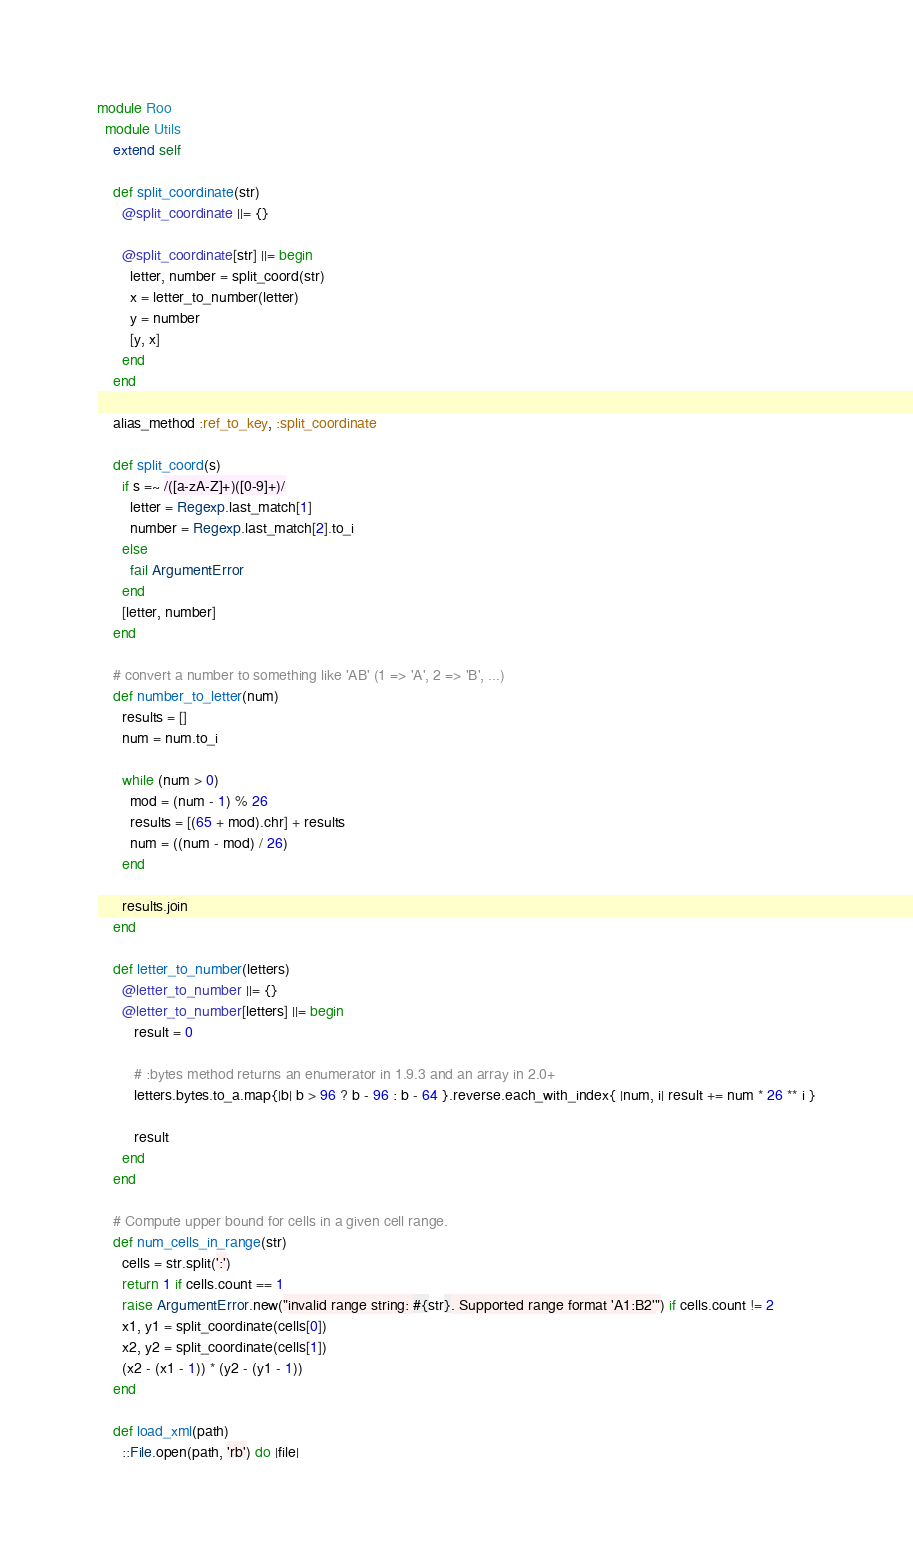Convert code to text. <code><loc_0><loc_0><loc_500><loc_500><_Ruby_>module Roo
  module Utils
    extend self

    def split_coordinate(str)
      @split_coordinate ||= {}

      @split_coordinate[str] ||= begin
        letter, number = split_coord(str)
        x = letter_to_number(letter)
        y = number
        [y, x]
      end
    end

    alias_method :ref_to_key, :split_coordinate

    def split_coord(s)
      if s =~ /([a-zA-Z]+)([0-9]+)/
        letter = Regexp.last_match[1]
        number = Regexp.last_match[2].to_i
      else
        fail ArgumentError
      end
      [letter, number]
    end

    # convert a number to something like 'AB' (1 => 'A', 2 => 'B', ...)
    def number_to_letter(num)
      results = []
      num = num.to_i

      while (num > 0)
        mod = (num - 1) % 26
        results = [(65 + mod).chr] + results
        num = ((num - mod) / 26)
      end

      results.join
    end

    def letter_to_number(letters)
      @letter_to_number ||= {}
      @letter_to_number[letters] ||= begin
         result = 0

         # :bytes method returns an enumerator in 1.9.3 and an array in 2.0+
         letters.bytes.to_a.map{|b| b > 96 ? b - 96 : b - 64 }.reverse.each_with_index{ |num, i| result += num * 26 ** i }

         result
      end
    end

    # Compute upper bound for cells in a given cell range.
    def num_cells_in_range(str)
      cells = str.split(':')
      return 1 if cells.count == 1
      raise ArgumentError.new("invalid range string: #{str}. Supported range format 'A1:B2'") if cells.count != 2
      x1, y1 = split_coordinate(cells[0])
      x2, y2 = split_coordinate(cells[1])
      (x2 - (x1 - 1)) * (y2 - (y1 - 1))
    end

    def load_xml(path)
      ::File.open(path, 'rb') do |file|</code> 